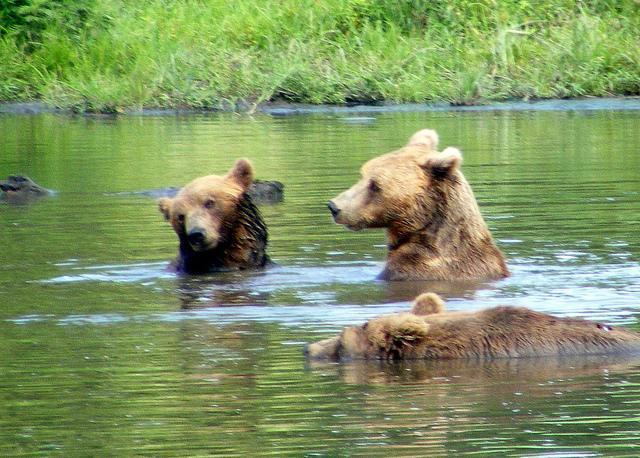How many bears are in this picture?
Give a very brief answer. 3. How many bears can be seen?
Give a very brief answer. 3. How many elephants are there?
Give a very brief answer. 0. 